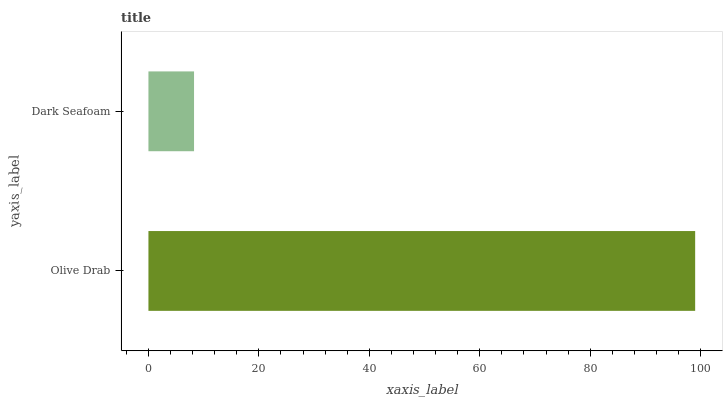Is Dark Seafoam the minimum?
Answer yes or no. Yes. Is Olive Drab the maximum?
Answer yes or no. Yes. Is Dark Seafoam the maximum?
Answer yes or no. No. Is Olive Drab greater than Dark Seafoam?
Answer yes or no. Yes. Is Dark Seafoam less than Olive Drab?
Answer yes or no. Yes. Is Dark Seafoam greater than Olive Drab?
Answer yes or no. No. Is Olive Drab less than Dark Seafoam?
Answer yes or no. No. Is Olive Drab the high median?
Answer yes or no. Yes. Is Dark Seafoam the low median?
Answer yes or no. Yes. Is Dark Seafoam the high median?
Answer yes or no. No. Is Olive Drab the low median?
Answer yes or no. No. 